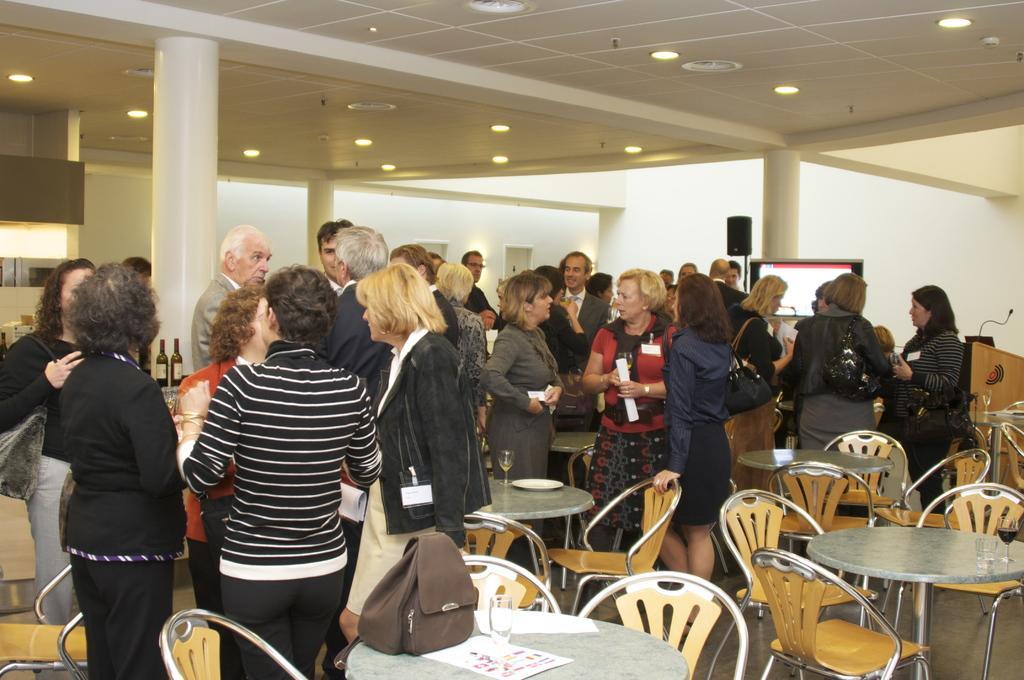In one or two sentences, can you explain what this image depicts? In this image I can see number of people are standing, I can also see few chairs and few tables. 